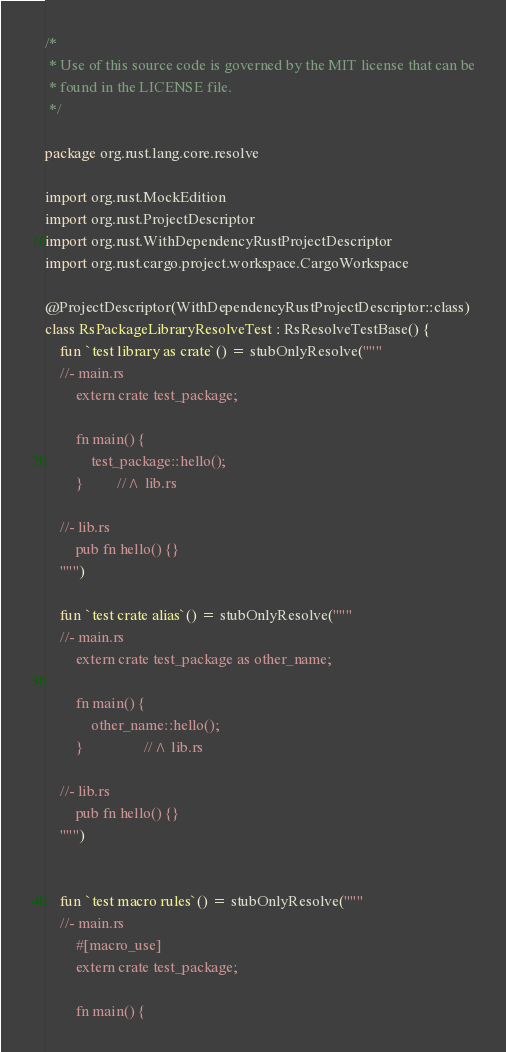Convert code to text. <code><loc_0><loc_0><loc_500><loc_500><_Kotlin_>/*
 * Use of this source code is governed by the MIT license that can be
 * found in the LICENSE file.
 */

package org.rust.lang.core.resolve

import org.rust.MockEdition
import org.rust.ProjectDescriptor
import org.rust.WithDependencyRustProjectDescriptor
import org.rust.cargo.project.workspace.CargoWorkspace

@ProjectDescriptor(WithDependencyRustProjectDescriptor::class)
class RsPackageLibraryResolveTest : RsResolveTestBase() {
    fun `test library as crate`() = stubOnlyResolve("""
    //- main.rs
        extern crate test_package;

        fn main() {
            test_package::hello();
        }         //^ lib.rs

    //- lib.rs
        pub fn hello() {}
    """)

    fun `test crate alias`() = stubOnlyResolve("""
    //- main.rs
        extern crate test_package as other_name;

        fn main() {
            other_name::hello();
        }                //^ lib.rs

    //- lib.rs
        pub fn hello() {}
    """)


    fun `test macro rules`() = stubOnlyResolve("""
    //- main.rs
        #[macro_use]
        extern crate test_package;

        fn main() {</code> 